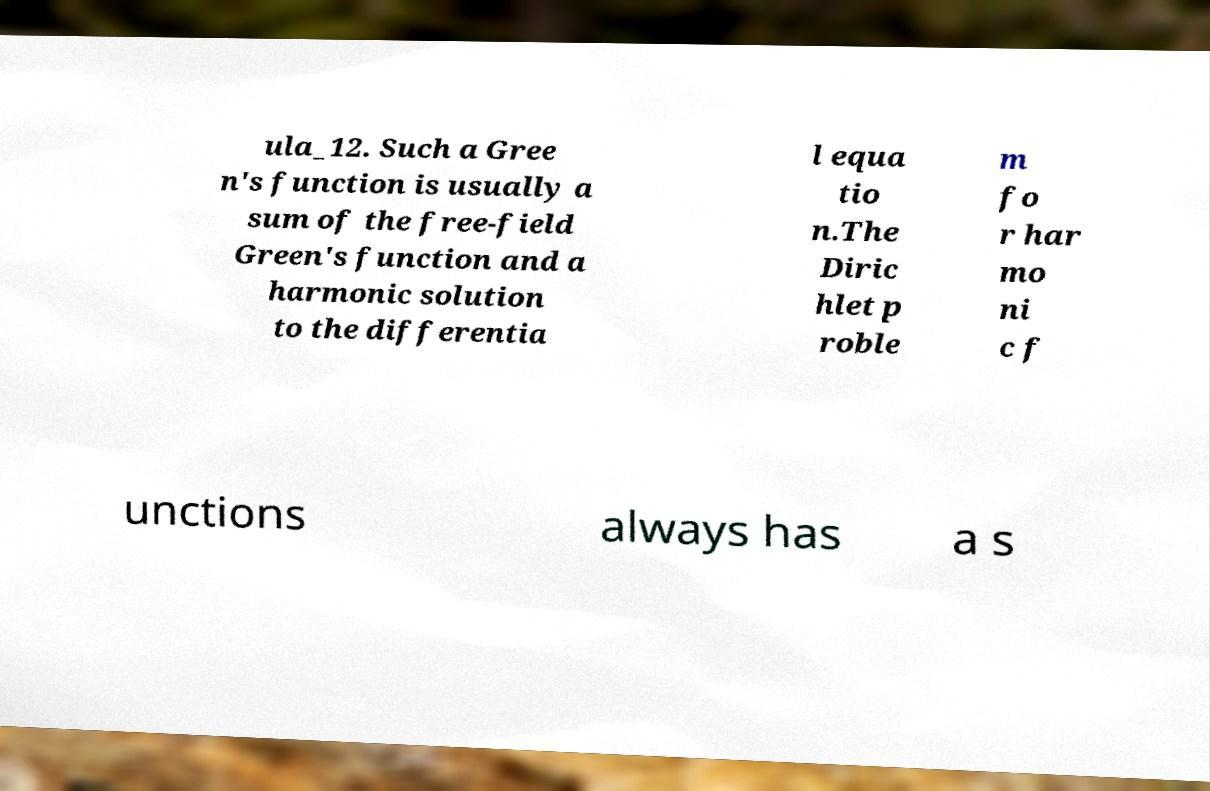There's text embedded in this image that I need extracted. Can you transcribe it verbatim? ula_12. Such a Gree n's function is usually a sum of the free-field Green's function and a harmonic solution to the differentia l equa tio n.The Diric hlet p roble m fo r har mo ni c f unctions always has a s 